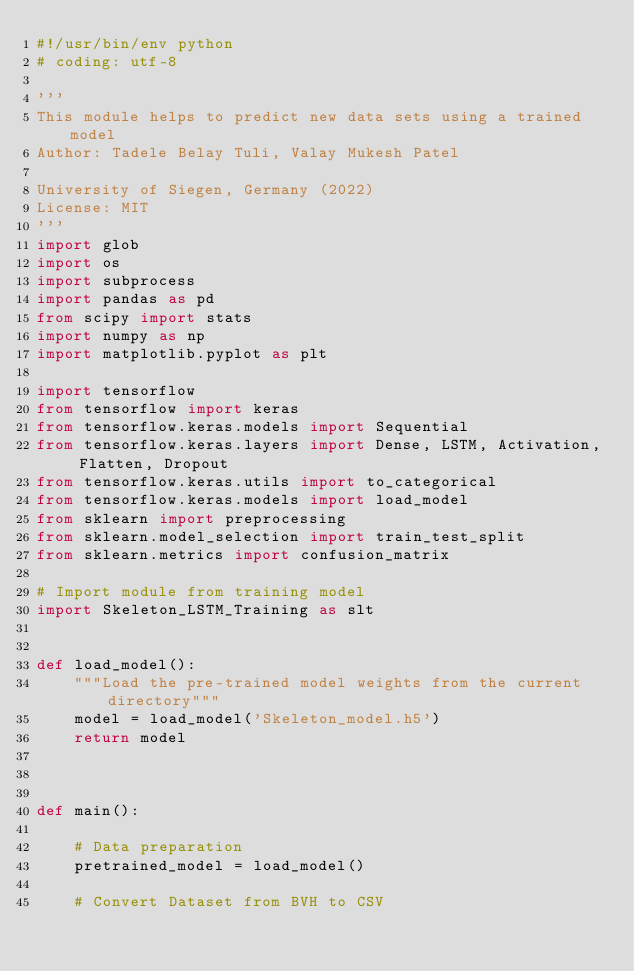<code> <loc_0><loc_0><loc_500><loc_500><_Python_>#!/usr/bin/env python
# coding: utf-8

'''
This module helps to predict new data sets using a trained model
Author: Tadele Belay Tuli, Valay Mukesh Patel 

University of Siegen, Germany (2022)
License: MIT
'''
import glob
import os
import subprocess
import pandas as pd
from scipy import stats
import numpy as np
import matplotlib.pyplot as plt

import tensorflow 
from tensorflow import keras
from tensorflow.keras.models import Sequential
from tensorflow.keras.layers import Dense, LSTM, Activation, Flatten, Dropout
from tensorflow.keras.utils import to_categorical
from tensorflow.keras.models import load_model
from sklearn import preprocessing
from sklearn.model_selection import train_test_split
from sklearn.metrics import confusion_matrix

# Import module from training model
import Skeleton_LSTM_Training as slt


def load_model():
    """Load the pre-trained model weights from the current directory"""
    model = load_model('Skeleton_model.h5')
    return model      



def main():

    # Data preparation
    pretrained_model = load_model()

    # Convert Dataset from BVH to CSV</code> 